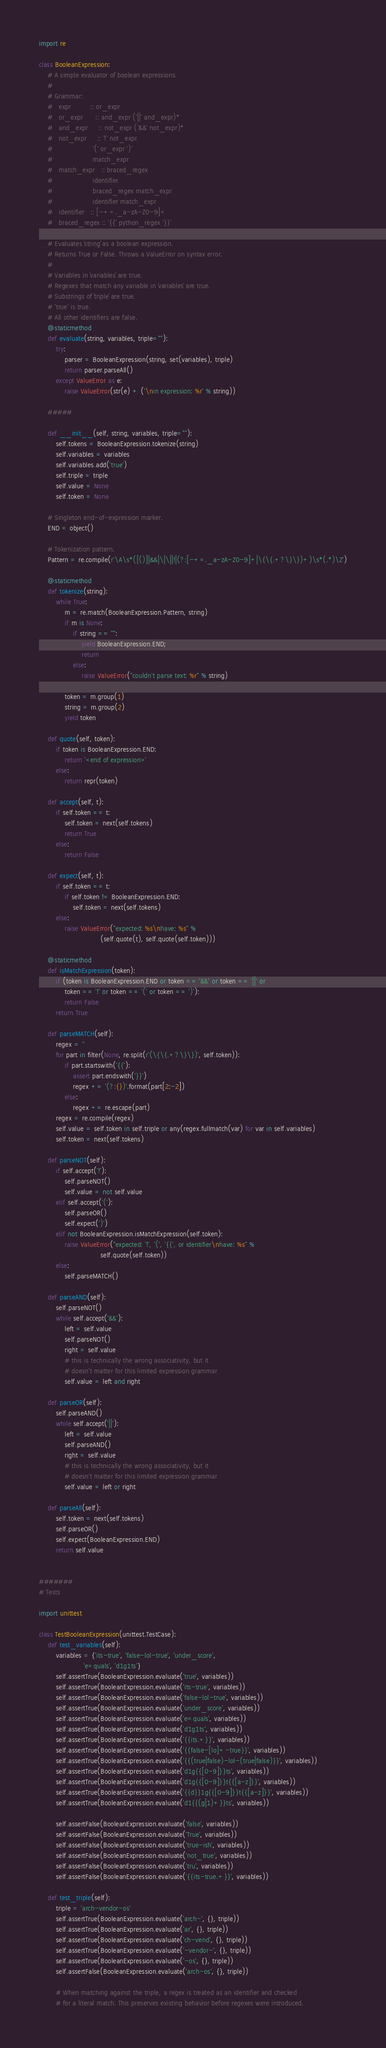<code> <loc_0><loc_0><loc_500><loc_500><_Python_>import re

class BooleanExpression:
    # A simple evaluator of boolean expressions.
    #
    # Grammar:
    #   expr         :: or_expr
    #   or_expr      :: and_expr ('||' and_expr)*
    #   and_expr     :: not_expr ('&&' not_expr)*
    #   not_expr     :: '!' not_expr
    #                   '(' or_expr ')'
    #                   match_expr
    #   match_expr   :: braced_regex
    #                   identifier
    #                   braced_regex match_expr
    #                   identifier match_expr
    #   identifier   :: [-+=._a-zA-Z0-9]+
    #   braced_regex :: '{{' python_regex '}}'

    # Evaluates `string` as a boolean expression.
    # Returns True or False. Throws a ValueError on syntax error.
    #
    # Variables in `variables` are true.
    # Regexes that match any variable in `variables` are true.
    # Substrings of `triple` are true.
    # 'true' is true.
    # All other identifiers are false.
    @staticmethod
    def evaluate(string, variables, triple=""):
        try:
            parser = BooleanExpression(string, set(variables), triple)
            return parser.parseAll()
        except ValueError as e:
            raise ValueError(str(e) + ('\nin expression: %r' % string))

    #####

    def __init__(self, string, variables, triple=""):
        self.tokens = BooleanExpression.tokenize(string)
        self.variables = variables
        self.variables.add('true')
        self.triple = triple
        self.value = None
        self.token = None

    # Singleton end-of-expression marker.
    END = object()

    # Tokenization pattern.
    Pattern = re.compile(r'\A\s*([()]|&&|\|\||!|(?:[-+=._a-zA-Z0-9]+|\{\{.+?\}\})+)\s*(.*)\Z')

    @staticmethod
    def tokenize(string):
        while True:
            m = re.match(BooleanExpression.Pattern, string)
            if m is None:
                if string == "":
                    yield BooleanExpression.END;
                    return
                else:
                    raise ValueError("couldn't parse text: %r" % string)

            token = m.group(1)
            string = m.group(2)
            yield token

    def quote(self, token):
        if token is BooleanExpression.END:
            return '<end of expression>'
        else:
            return repr(token)

    def accept(self, t):
        if self.token == t:
            self.token = next(self.tokens)
            return True
        else:
            return False

    def expect(self, t):
        if self.token == t:
            if self.token != BooleanExpression.END:
                self.token = next(self.tokens)
        else:
            raise ValueError("expected: %s\nhave: %s" %
                             (self.quote(t), self.quote(self.token)))

    @staticmethod
    def isMatchExpression(token):
        if (token is BooleanExpression.END or token == '&&' or token == '||' or
            token == '!' or token == '(' or token == ')'):
            return False
        return True

    def parseMATCH(self):
        regex = ''
        for part in filter(None, re.split(r'(\{\{.+?\}\})', self.token)):
            if part.startswith('{{'):
                assert part.endswith('}}')
                regex += '(?:{})'.format(part[2:-2])
            else:
                regex += re.escape(part)
        regex = re.compile(regex)
        self.value = self.token in self.triple or any(regex.fullmatch(var) for var in self.variables)
        self.token = next(self.tokens)

    def parseNOT(self):
        if self.accept('!'):
            self.parseNOT()
            self.value = not self.value
        elif self.accept('('):
            self.parseOR()
            self.expect(')')
        elif not BooleanExpression.isMatchExpression(self.token):
            raise ValueError("expected: '!', '(', '{{', or identifier\nhave: %s" %
                             self.quote(self.token))
        else:
            self.parseMATCH()

    def parseAND(self):
        self.parseNOT()
        while self.accept('&&'):
            left = self.value
            self.parseNOT()
            right = self.value
            # this is technically the wrong associativity, but it
            # doesn't matter for this limited expression grammar
            self.value = left and right

    def parseOR(self):
        self.parseAND()
        while self.accept('||'):
            left = self.value
            self.parseAND()
            right = self.value
            # this is technically the wrong associativity, but it
            # doesn't matter for this limited expression grammar
            self.value = left or right

    def parseAll(self):
        self.token = next(self.tokens)
        self.parseOR()
        self.expect(BooleanExpression.END)
        return self.value


#######
# Tests

import unittest

class TestBooleanExpression(unittest.TestCase):
    def test_variables(self):
        variables = {'its-true', 'false-lol-true', 'under_score',
                     'e=quals', 'd1g1ts'}
        self.assertTrue(BooleanExpression.evaluate('true', variables))
        self.assertTrue(BooleanExpression.evaluate('its-true', variables))
        self.assertTrue(BooleanExpression.evaluate('false-lol-true', variables))
        self.assertTrue(BooleanExpression.evaluate('under_score', variables))
        self.assertTrue(BooleanExpression.evaluate('e=quals', variables))
        self.assertTrue(BooleanExpression.evaluate('d1g1ts', variables))
        self.assertTrue(BooleanExpression.evaluate('{{its.+}}', variables))
        self.assertTrue(BooleanExpression.evaluate('{{false-[lo]+-true}}', variables))
        self.assertTrue(BooleanExpression.evaluate('{{(true|false)-lol-(true|false)}}', variables))
        self.assertTrue(BooleanExpression.evaluate('d1g{{[0-9]}}ts', variables))
        self.assertTrue(BooleanExpression.evaluate('d1g{{[0-9]}}t{{[a-z]}}', variables))
        self.assertTrue(BooleanExpression.evaluate('{{d}}1g{{[0-9]}}t{{[a-z]}}', variables))
        self.assertTrue(BooleanExpression.evaluate('d1{{(g|1)+}}ts', variables))

        self.assertFalse(BooleanExpression.evaluate('false', variables))
        self.assertFalse(BooleanExpression.evaluate('True', variables))
        self.assertFalse(BooleanExpression.evaluate('true-ish', variables))
        self.assertFalse(BooleanExpression.evaluate('not_true', variables))
        self.assertFalse(BooleanExpression.evaluate('tru', variables))
        self.assertFalse(BooleanExpression.evaluate('{{its-true.+}}', variables))

    def test_triple(self):
        triple = 'arch-vendor-os'
        self.assertTrue(BooleanExpression.evaluate('arch-', {}, triple))
        self.assertTrue(BooleanExpression.evaluate('ar', {}, triple))
        self.assertTrue(BooleanExpression.evaluate('ch-vend', {}, triple))
        self.assertTrue(BooleanExpression.evaluate('-vendor-', {}, triple))
        self.assertTrue(BooleanExpression.evaluate('-os', {}, triple))
        self.assertFalse(BooleanExpression.evaluate('arch-os', {}, triple))

        # When matching against the triple, a regex is treated as an identifier and checked
        # for a literal match. This preserves existing behavior before regexes were introduced.</code> 